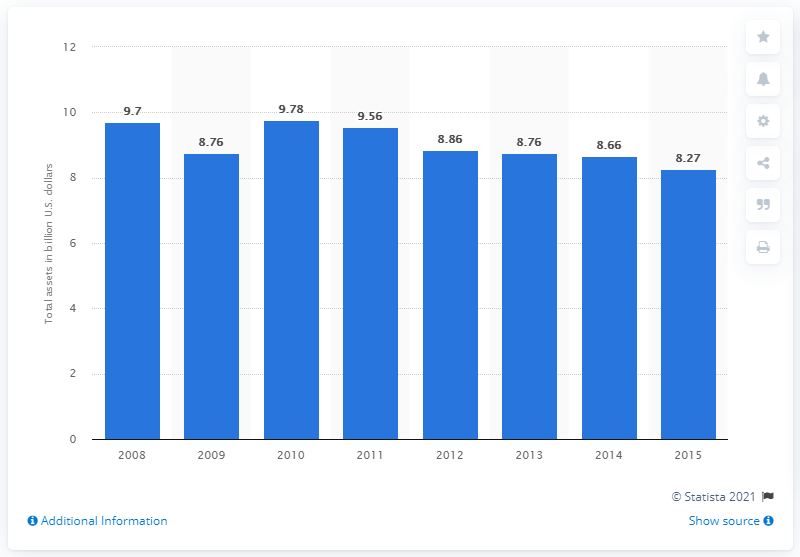Draw attention to some important aspects in this diagram. In 2015, the total assets of Starwood Hotels & Resorts were 8.27 billion dollars. 